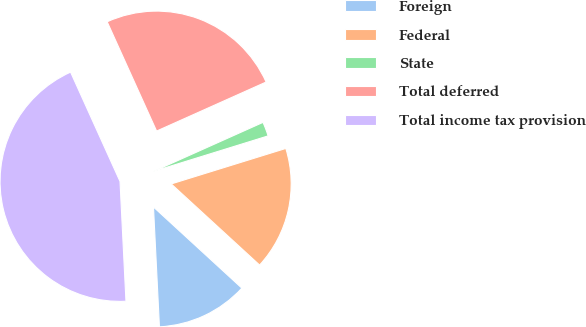<chart> <loc_0><loc_0><loc_500><loc_500><pie_chart><fcel>Foreign<fcel>Federal<fcel>State<fcel>Total deferred<fcel>Total income tax provision<nl><fcel>12.39%<fcel>16.6%<fcel>1.92%<fcel>25.06%<fcel>44.03%<nl></chart> 